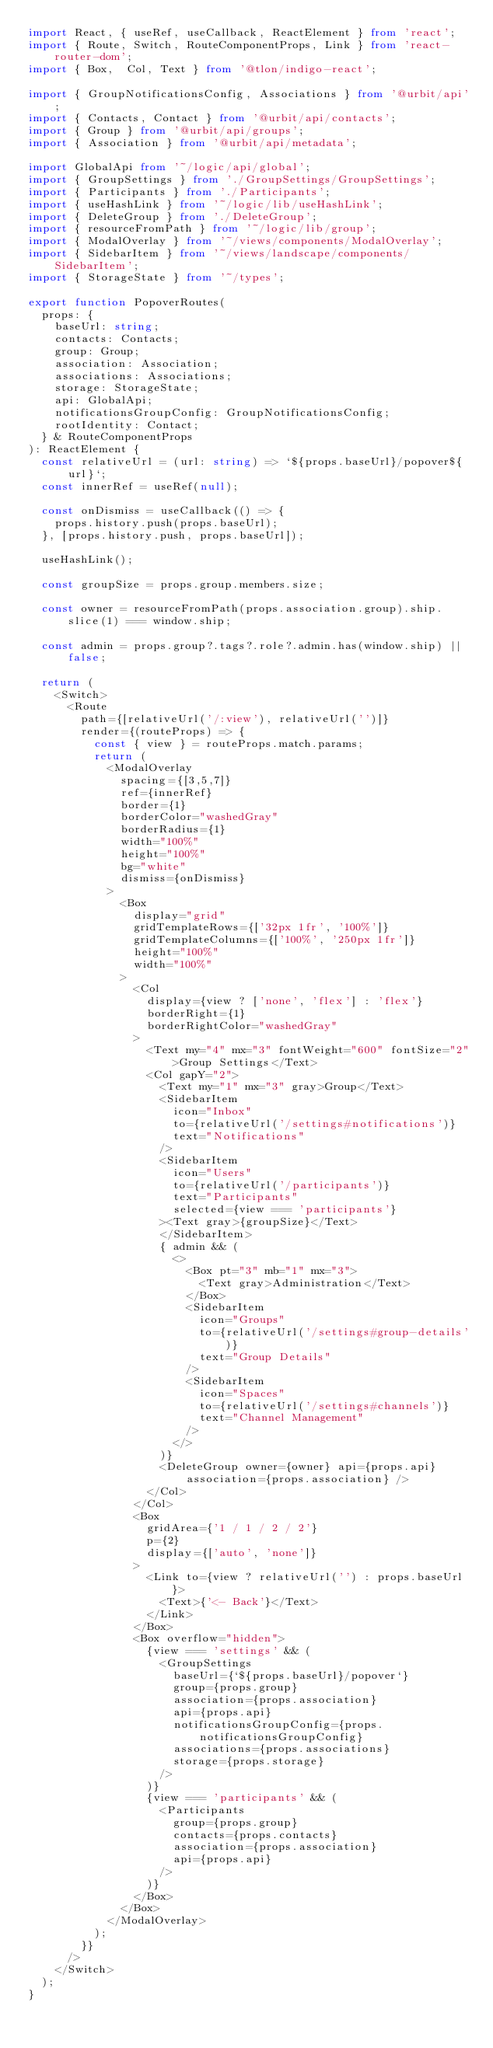<code> <loc_0><loc_0><loc_500><loc_500><_TypeScript_>import React, { useRef, useCallback, ReactElement } from 'react';
import { Route, Switch, RouteComponentProps, Link } from 'react-router-dom';
import { Box,  Col, Text } from '@tlon/indigo-react';

import { GroupNotificationsConfig, Associations } from '@urbit/api';
import { Contacts, Contact } from '@urbit/api/contacts';
import { Group } from '@urbit/api/groups';
import { Association } from '@urbit/api/metadata';

import GlobalApi from '~/logic/api/global';
import { GroupSettings } from './GroupSettings/GroupSettings';
import { Participants } from './Participants';
import { useHashLink } from '~/logic/lib/useHashLink';
import { DeleteGroup } from './DeleteGroup';
import { resourceFromPath } from '~/logic/lib/group';
import { ModalOverlay } from '~/views/components/ModalOverlay';
import { SidebarItem } from '~/views/landscape/components/SidebarItem';
import { StorageState } from '~/types';

export function PopoverRoutes(
  props: {
    baseUrl: string;
    contacts: Contacts;
    group: Group;
    association: Association;
    associations: Associations;
    storage: StorageState;
    api: GlobalApi;
    notificationsGroupConfig: GroupNotificationsConfig;
    rootIdentity: Contact;
  } & RouteComponentProps
): ReactElement {
  const relativeUrl = (url: string) => `${props.baseUrl}/popover${url}`;
  const innerRef = useRef(null);

  const onDismiss = useCallback(() => {
    props.history.push(props.baseUrl);
  }, [props.history.push, props.baseUrl]);

  useHashLink();

  const groupSize = props.group.members.size;

  const owner = resourceFromPath(props.association.group).ship.slice(1) === window.ship;

  const admin = props.group?.tags?.role?.admin.has(window.ship) || false;

  return (
    <Switch>
      <Route
        path={[relativeUrl('/:view'), relativeUrl('')]}
        render={(routeProps) => {
          const { view } = routeProps.match.params;
          return (
            <ModalOverlay
              spacing={[3,5,7]}
              ref={innerRef}
              border={1}
              borderColor="washedGray"
              borderRadius={1}
              width="100%"
              height="100%"
              bg="white"
              dismiss={onDismiss}
            >
              <Box
                display="grid"
                gridTemplateRows={['32px 1fr', '100%']}
                gridTemplateColumns={['100%', '250px 1fr']}
                height="100%"
                width="100%"
              >
                <Col
                  display={view ? ['none', 'flex'] : 'flex'}
                  borderRight={1}
                  borderRightColor="washedGray"
                >
                  <Text my="4" mx="3" fontWeight="600" fontSize="2">Group Settings</Text>
                  <Col gapY="2">
                    <Text my="1" mx="3" gray>Group</Text>
                    <SidebarItem
                      icon="Inbox"
                      to={relativeUrl('/settings#notifications')}
                      text="Notifications"
                    />
                    <SidebarItem
                      icon="Users"
                      to={relativeUrl('/participants')}
                      text="Participants"
                      selected={view === 'participants'}
                    ><Text gray>{groupSize}</Text>
                    </SidebarItem>
                    { admin && (
                      <>
                        <Box pt="3" mb="1" mx="3">
                          <Text gray>Administration</Text>
                        </Box>
                        <SidebarItem
                          icon="Groups"
                          to={relativeUrl('/settings#group-details')}
                          text="Group Details"
                        />
                        <SidebarItem
                          icon="Spaces"
                          to={relativeUrl('/settings#channels')}
                          text="Channel Management"
                        />
                      </>
                    )}
                    <DeleteGroup owner={owner} api={props.api} association={props.association} />
                  </Col>
                </Col>
                <Box
                  gridArea={'1 / 1 / 2 / 2'}
                  p={2}
                  display={['auto', 'none']}
                >
                  <Link to={view ? relativeUrl('') : props.baseUrl}>
                    <Text>{'<- Back'}</Text>
                  </Link>
                </Box>
                <Box overflow="hidden">
                  {view === 'settings' && (
                    <GroupSettings
                      baseUrl={`${props.baseUrl}/popover`}
                      group={props.group}
                      association={props.association}
                      api={props.api}
                      notificationsGroupConfig={props.notificationsGroupConfig}
                      associations={props.associations}
                      storage={props.storage}
                    />
                  )}
                  {view === 'participants' && (
                    <Participants
                      group={props.group}
                      contacts={props.contacts}
                      association={props.association}
                      api={props.api}
                    />
                  )}
                </Box>
              </Box>
            </ModalOverlay>
          );
        }}
      />
    </Switch>
  );
}
</code> 